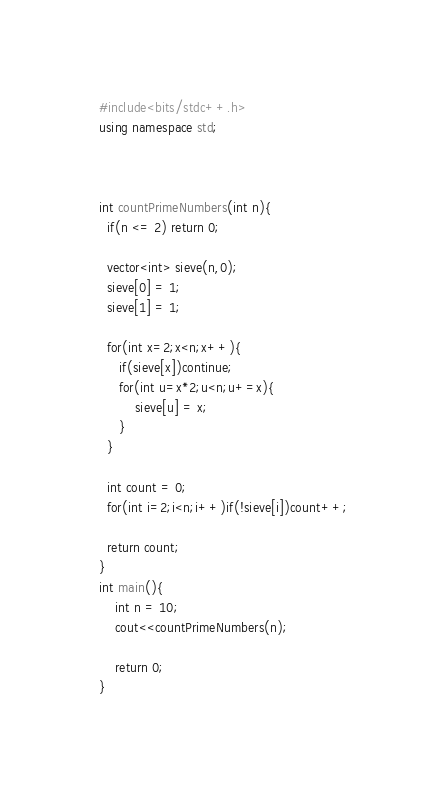Convert code to text. <code><loc_0><loc_0><loc_500><loc_500><_C++_>#include<bits/stdc++.h>
using namespace std;



int countPrimeNumbers(int n){
  if(n <= 2) return 0;

  vector<int> sieve(n,0);
  sieve[0] = 1;
  sieve[1] = 1;

  for(int x=2;x<n;x++){
     if(sieve[x])continue;
     for(int u=x*2;u<n;u+=x){ 
         sieve[u] = x;
     }
  }

  int count = 0;
  for(int i=2;i<n;i++)if(!sieve[i])count++;

  return count;
}
int main(){
    int n = 10;
    cout<<countPrimeNumbers(n);

    return 0;
}</code> 